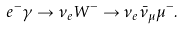<formula> <loc_0><loc_0><loc_500><loc_500>e ^ { - } \gamma \to \nu _ { e } W ^ { - } \to \nu _ { e } \bar { \nu } _ { \mu } \mu ^ { - } .</formula> 